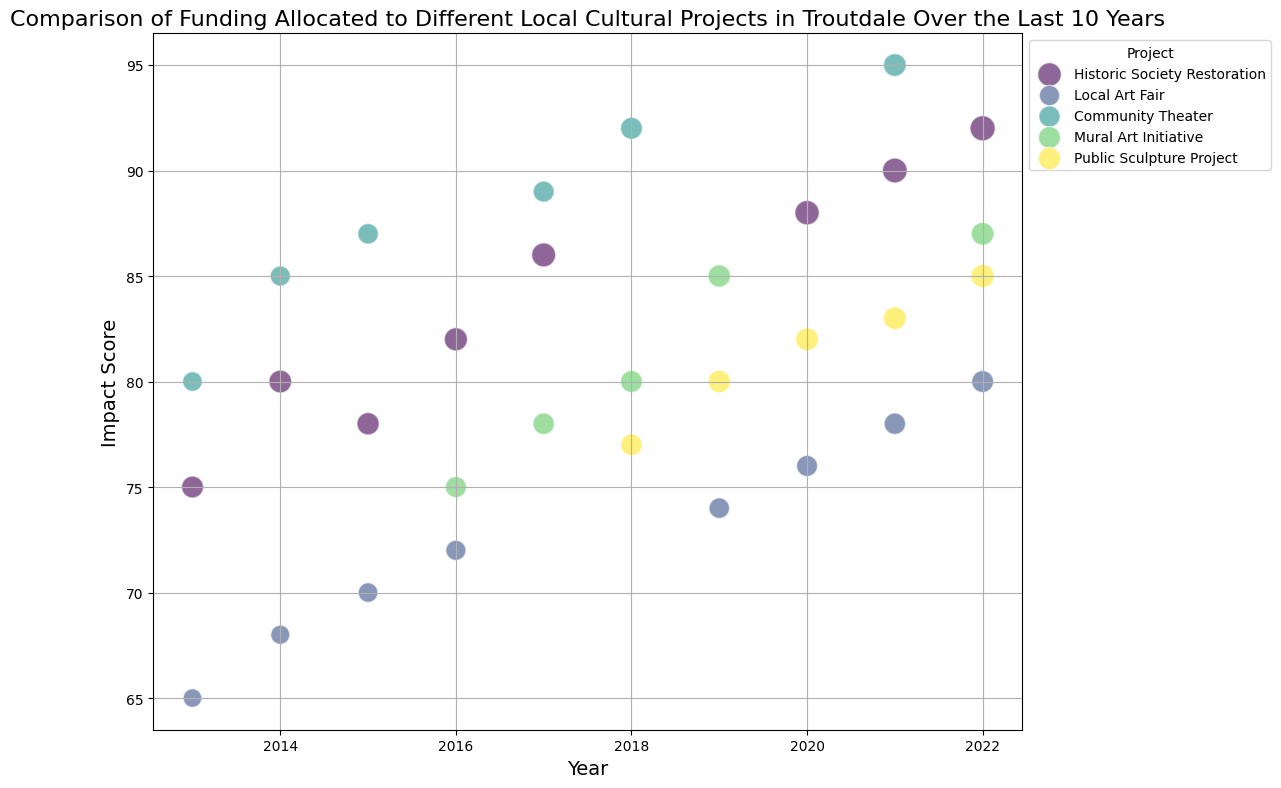What's the project with the highest impact score in 2022? Look at the Impact scores for the year 2022. The Historic Society Restoration has the highest impact score at 92.
Answer: Historic Society Restoration Which project had the largest bubble size in 2017? Identify the project with the largest bubble size in the year 2017. The Historic Society Restoration had the largest bubble size of 3.0.
Answer: Historic Society Restoration How did the funding for the Local Art Fair change from 2019 to 2020? Compare the funding amount for the Local Art Fair between 2019 and 2020. In 2019, it was 23000, and in 2020, it increased to 25000.
Answer: Increased What is the average impact score for the Public Sculpture Project from 2018 to 2022? The Impact scores for the Public Sculpture Project from 2018 to 2022 are 77, 80, 82, 83, and 85. The average is (77 + 80 + 82 + 83 + 85) / 5 = 81.4
Answer: 81.4 Which project had the smallest increase in funding between 2014 and 2015? Compare the change in funding for the projects between 2014 and 2015: 
Historic Society Restoration changed from 40000 to 38000 (-2000), 
Local Art Fair changed from 15000 to 18000 (+3000), 
Community Theater changed from 22000 to 24000 (+2000). The smallest increase (or negative change) is for the Historic Society Restoration.
Answer: Historic Society Restoration Which project received the most consistent level of funding over the years? By visually inspecting the plot, the Local Art Fair appears to have relatively consistent bubbles in size over the years, indicating funding consistency.
Answer: Local Art Fair What year did the Community Theater achieve its highest impact score? Look at the Impact scores for the Community Theater across all years, identifying the highest score. The highest impact score is 95, achieved in 2021.
Answer: 2021 In which year did the Mural Art Initiative first appear in the data? Identify the first occurrence of the Mural Art Initiative on the x-axis representing the years. It first appears in 2016.
Answer: 2016 For which years were different cultural projects funded the most equally, based on bubble sizes? Identify the years in which bubble sizes for different projects are most similar. Year 2019 shows relatively similar bubble sizes for multiple projects such as Local Art Fair, Mural Art Initiative, and Public Sculpture Project.
Answer: 2019 